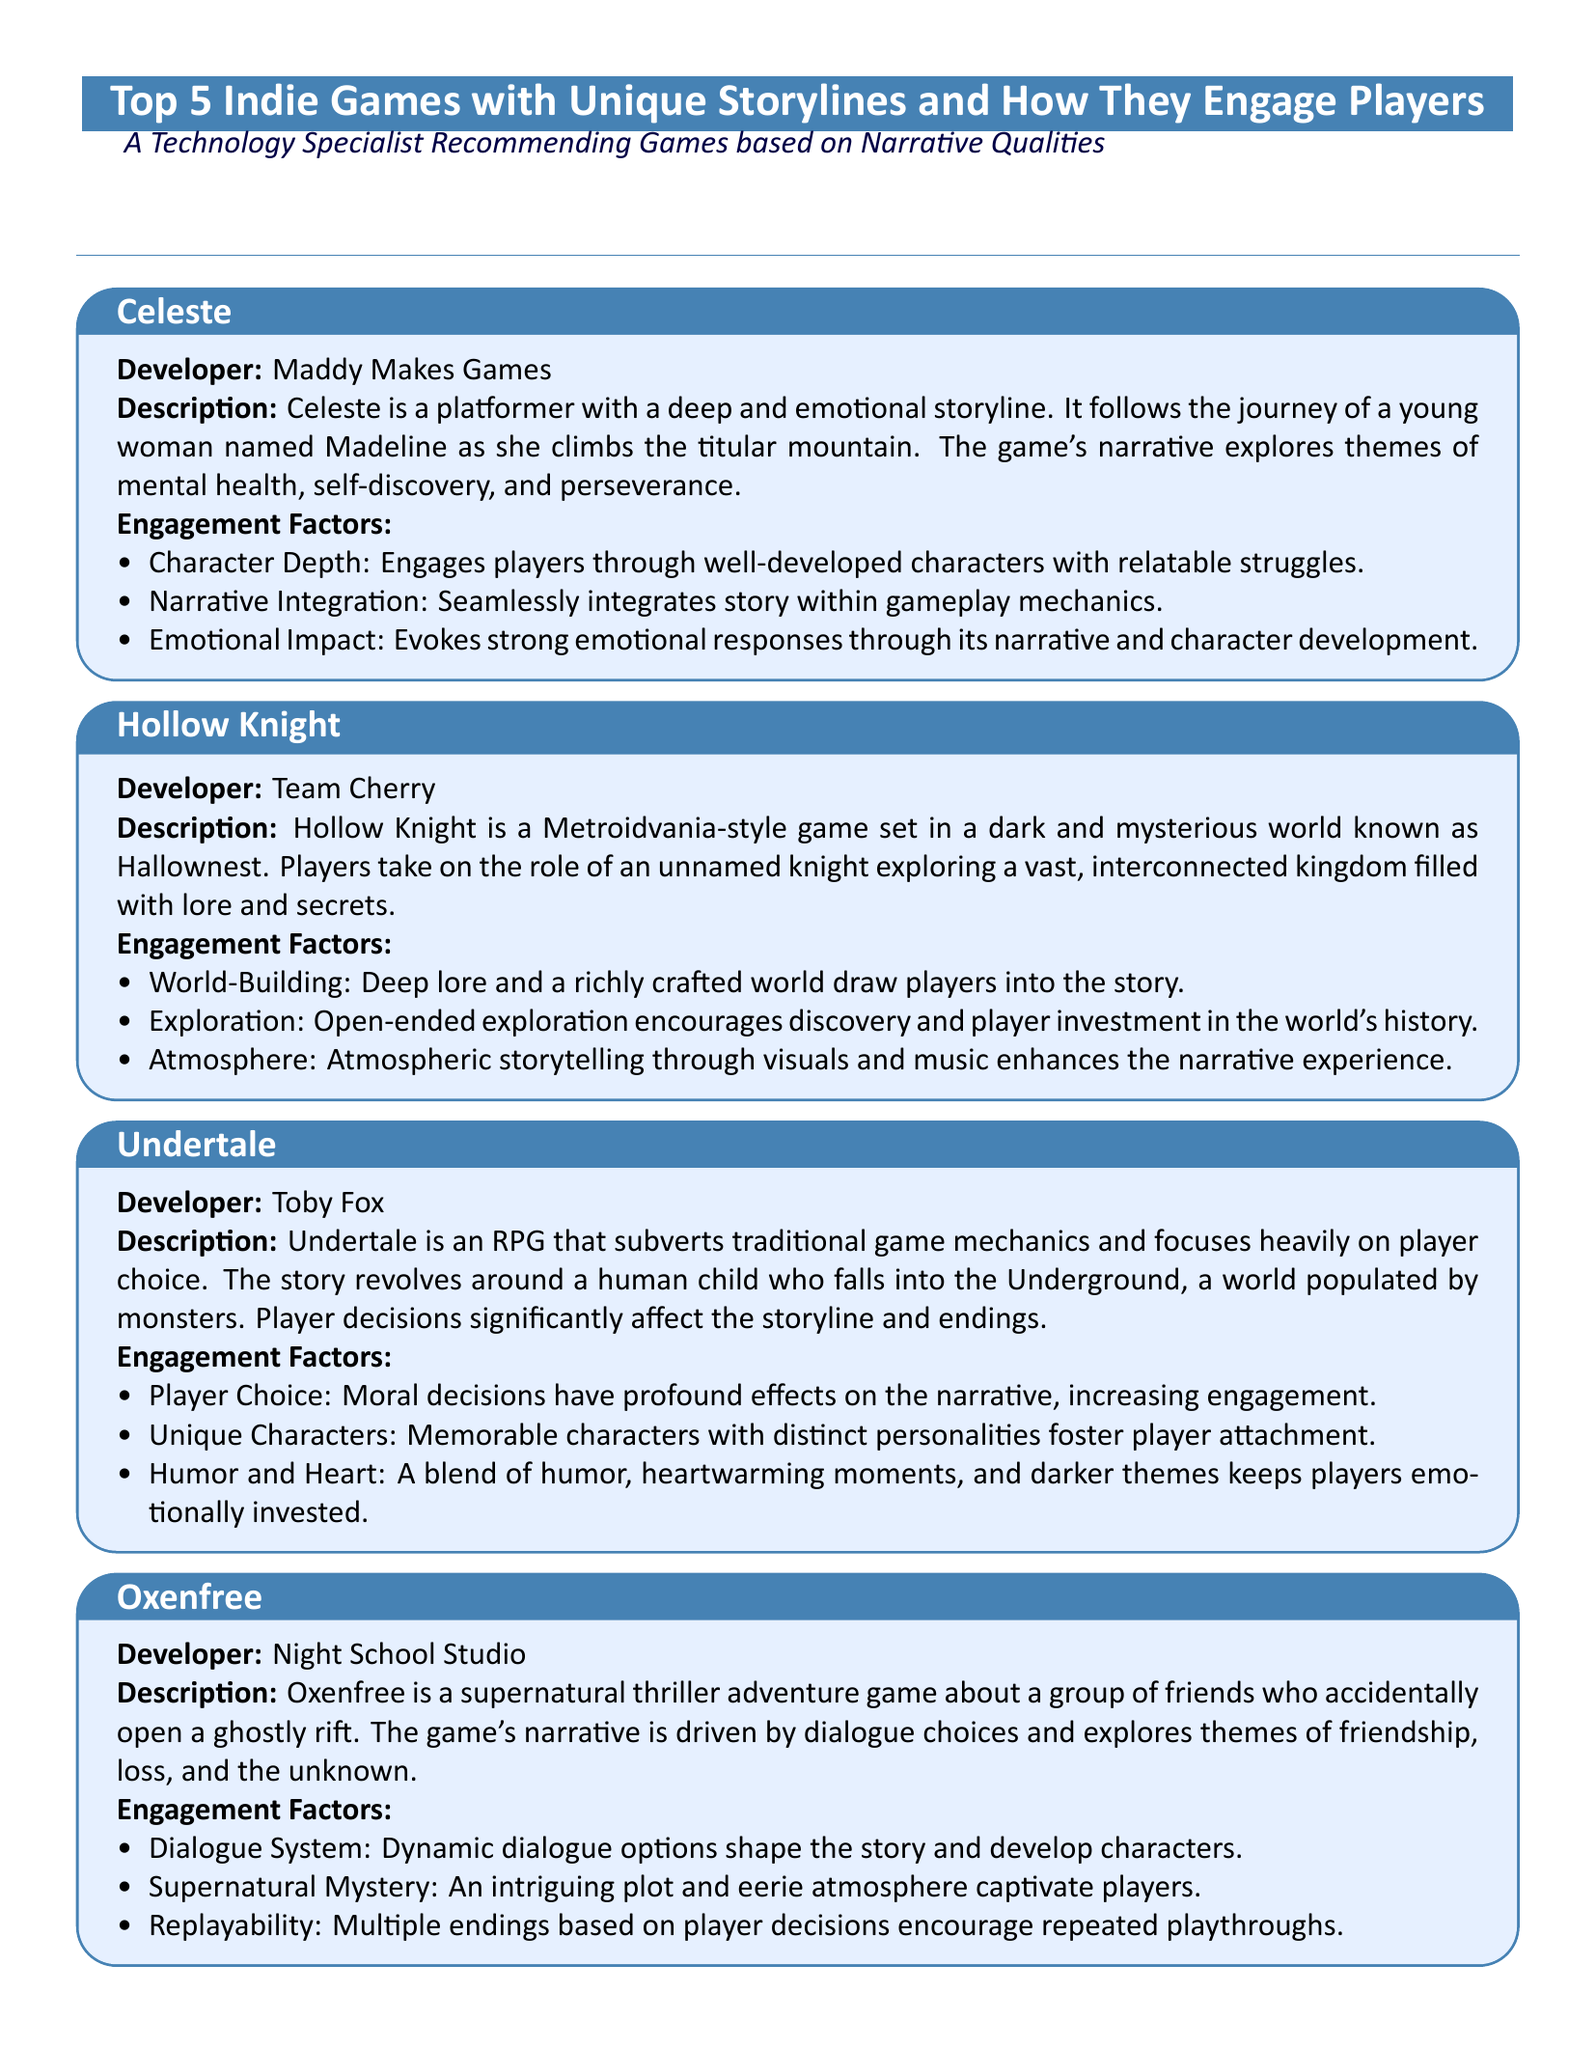What is the name of the game developed by Maddy Makes Games? The document provides the name of the game created by Maddy Makes Games, which is "Celeste."
Answer: Celeste Which developer created "Hollow Knight"? The document states that "Hollow Knight" was developed by Team Cherry.
Answer: Team Cherry How many games are listed in the document? The document mentions a total of five indie games highlighted for their unique storylines.
Answer: 5 What main theme does "Spiritfarer" explore? The document states that "Spiritfarer" explores themes of life, death, and letting go.
Answer: Life, death, and letting go What engagement factor is highlighted for "Undertale"? The document lists "Player Choice" as a key engagement factor that significantly affects the narrative in "Undertale."
Answer: Player Choice Which game features a dynamic dialogue system? According to the document, "Oxenfree" is the game that includes a dynamic dialogue system that shapes the story.
Answer: Oxenfree What type of game is "Celeste"? The document describes "Celeste" as a platformer game.
Answer: Platformer Name one engagement factor of "Hollow Knight." The document highlights "World-Building" as one of the engagement factors for "Hollow Knight."
Answer: World-Building In which game do players guide spirits to their final resting place? The document states that in "Spiritfarer," players guide spirits to their final resting place.
Answer: Spiritfarer 